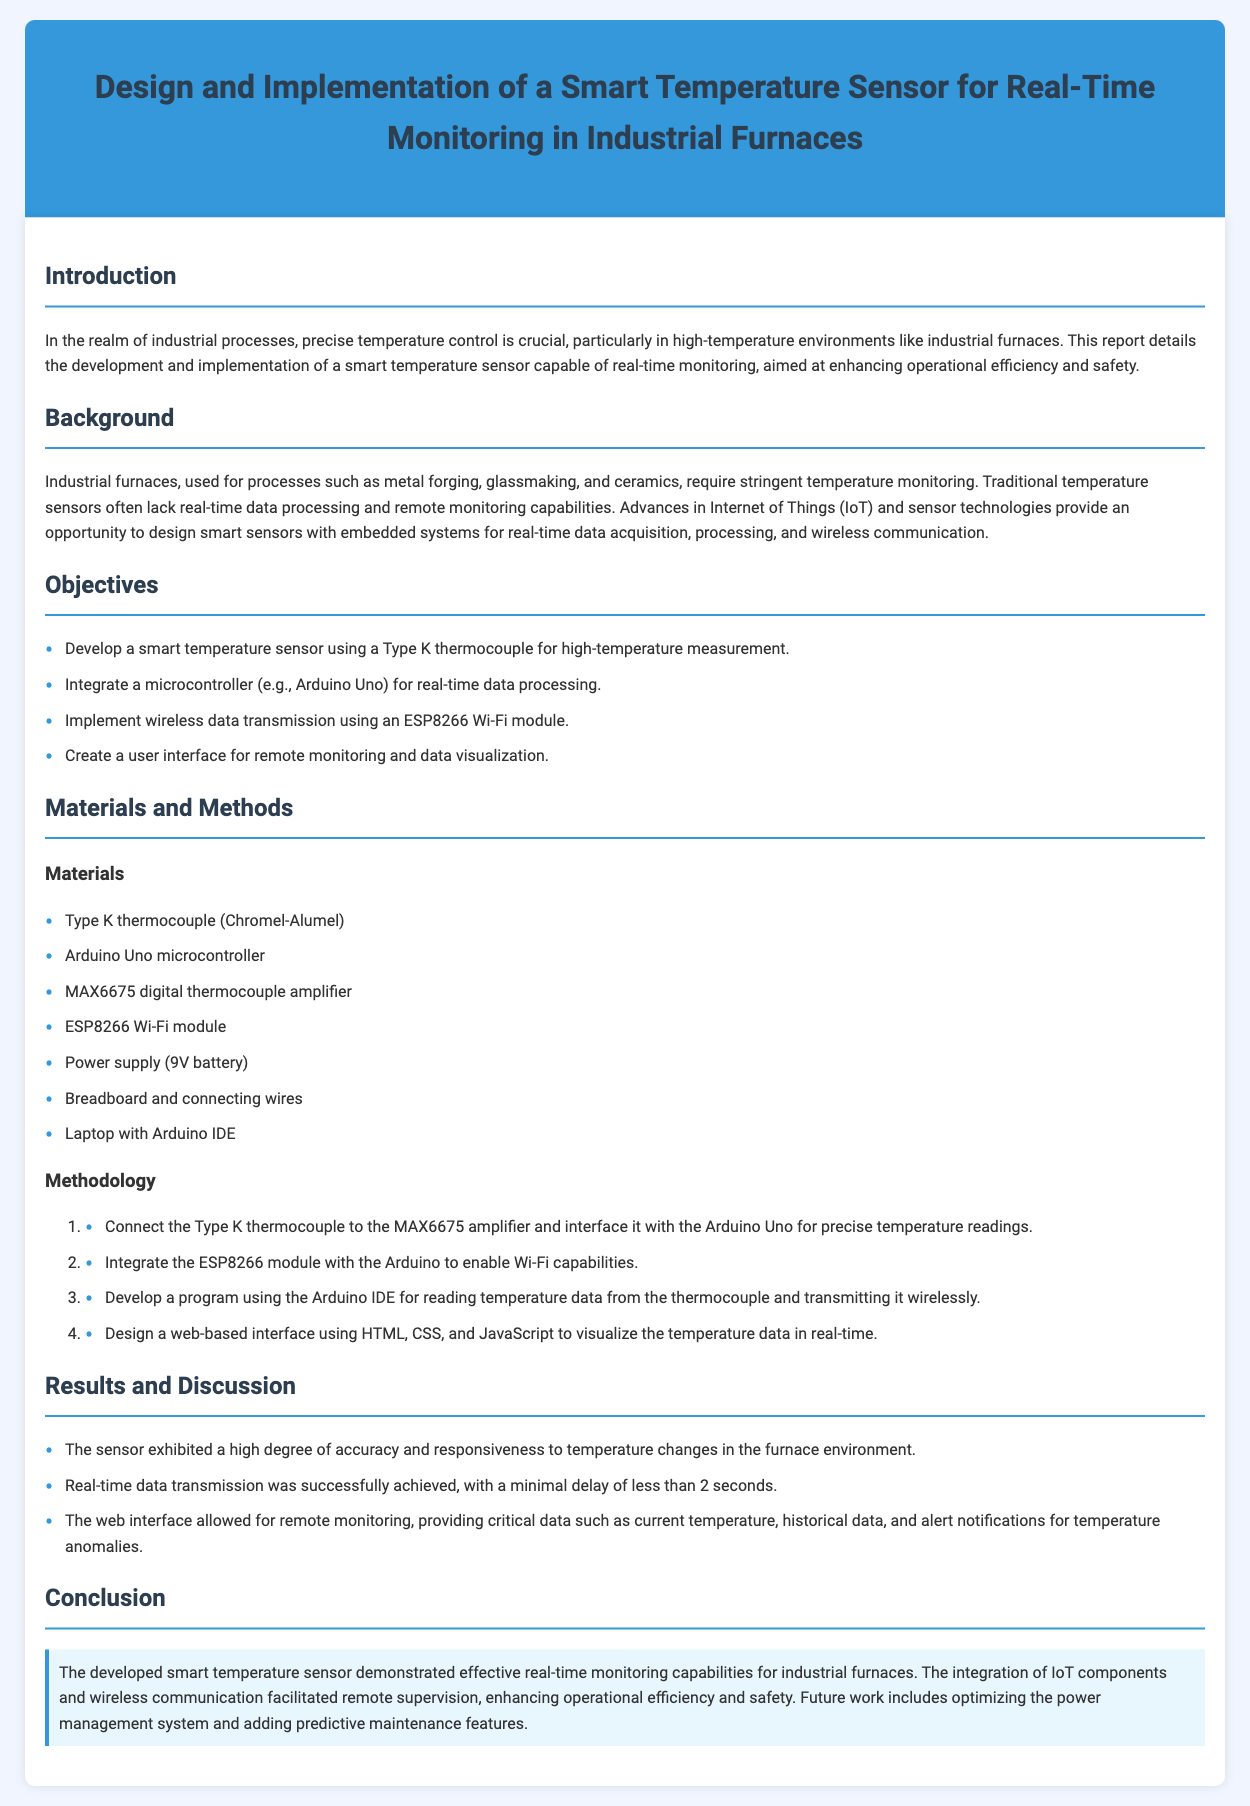what type of thermocouple is used in the smart sensor? The document specifies that a Type K thermocouple is used for high-temperature measurement in the smart sensor.
Answer: Type K what microcontroller is integrated for real-time processing? The microcontroller used in the smart temperature sensor for real-time data processing is mentioned as an Arduino Uno.
Answer: Arduino Uno how long is the delay for real-time data transmission? The report states that real-time data transmission was achieved with a minimal delay of less than 2 seconds.
Answer: less than 2 seconds what is one of the objectives of the smart temperature sensor project? One of the objectives mentioned is to integrate wireless data transmission using an ESP8266 Wi-Fi module.
Answer: wireless data transmission using an ESP8266 Wi-Fi module which programming environment was used for developing the sensor's interface? The document indicates that the development of the program for the sensor was done using the Arduino IDE.
Answer: Arduino IDE what is the main benefit of the smart temperature sensor mentioned in the conclusion? The conclusion highlights that the sensor facilitates remote supervision, enhancing operational efficiency and safety.
Answer: remote supervision what materials are listed as essential for the sensor's implementation? The materials section lists components like a Type K thermocouple and an ESP8266 Wi-Fi module as essential for implementation.
Answer: Type K thermocouple, ESP8266 Wi-Fi module what surrounds the section titles in the document? The section titles in the document are surrounded by a solid border below to distinguish them from the content.
Answer: solid border what future improvement is mentioned for the smart temperature sensor? The conclusion suggests that future work includes optimizing the power management system as a potential improvement.
Answer: optimizing the power management system 